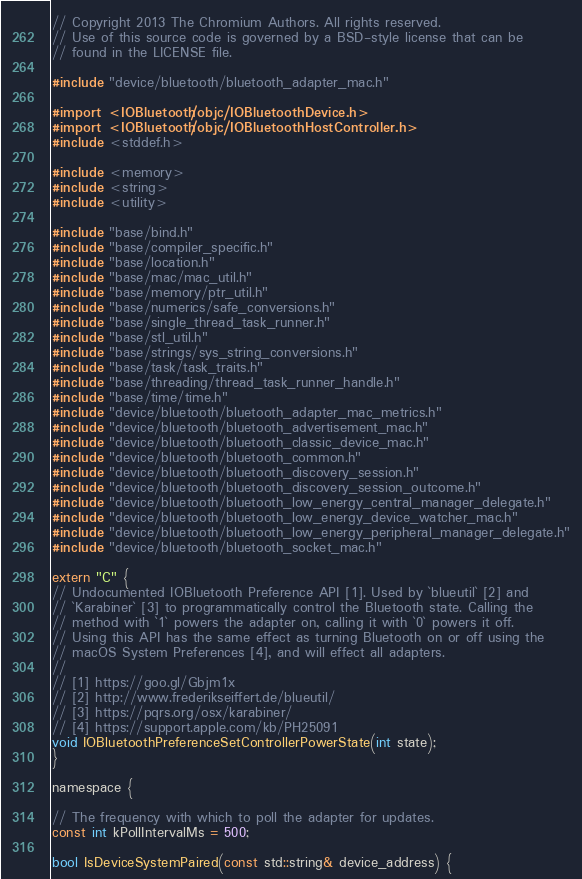Convert code to text. <code><loc_0><loc_0><loc_500><loc_500><_ObjectiveC_>// Copyright 2013 The Chromium Authors. All rights reserved.
// Use of this source code is governed by a BSD-style license that can be
// found in the LICENSE file.

#include "device/bluetooth/bluetooth_adapter_mac.h"

#import <IOBluetooth/objc/IOBluetoothDevice.h>
#import <IOBluetooth/objc/IOBluetoothHostController.h>
#include <stddef.h>

#include <memory>
#include <string>
#include <utility>

#include "base/bind.h"
#include "base/compiler_specific.h"
#include "base/location.h"
#include "base/mac/mac_util.h"
#include "base/memory/ptr_util.h"
#include "base/numerics/safe_conversions.h"
#include "base/single_thread_task_runner.h"
#include "base/stl_util.h"
#include "base/strings/sys_string_conversions.h"
#include "base/task/task_traits.h"
#include "base/threading/thread_task_runner_handle.h"
#include "base/time/time.h"
#include "device/bluetooth/bluetooth_adapter_mac_metrics.h"
#include "device/bluetooth/bluetooth_advertisement_mac.h"
#include "device/bluetooth/bluetooth_classic_device_mac.h"
#include "device/bluetooth/bluetooth_common.h"
#include "device/bluetooth/bluetooth_discovery_session.h"
#include "device/bluetooth/bluetooth_discovery_session_outcome.h"
#include "device/bluetooth/bluetooth_low_energy_central_manager_delegate.h"
#include "device/bluetooth/bluetooth_low_energy_device_watcher_mac.h"
#include "device/bluetooth/bluetooth_low_energy_peripheral_manager_delegate.h"
#include "device/bluetooth/bluetooth_socket_mac.h"

extern "C" {
// Undocumented IOBluetooth Preference API [1]. Used by `blueutil` [2] and
// `Karabiner` [3] to programmatically control the Bluetooth state. Calling the
// method with `1` powers the adapter on, calling it with `0` powers it off.
// Using this API has the same effect as turning Bluetooth on or off using the
// macOS System Preferences [4], and will effect all adapters.
//
// [1] https://goo.gl/Gbjm1x
// [2] http://www.frederikseiffert.de/blueutil/
// [3] https://pqrs.org/osx/karabiner/
// [4] https://support.apple.com/kb/PH25091
void IOBluetoothPreferenceSetControllerPowerState(int state);
}

namespace {

// The frequency with which to poll the adapter for updates.
const int kPollIntervalMs = 500;

bool IsDeviceSystemPaired(const std::string& device_address) {</code> 